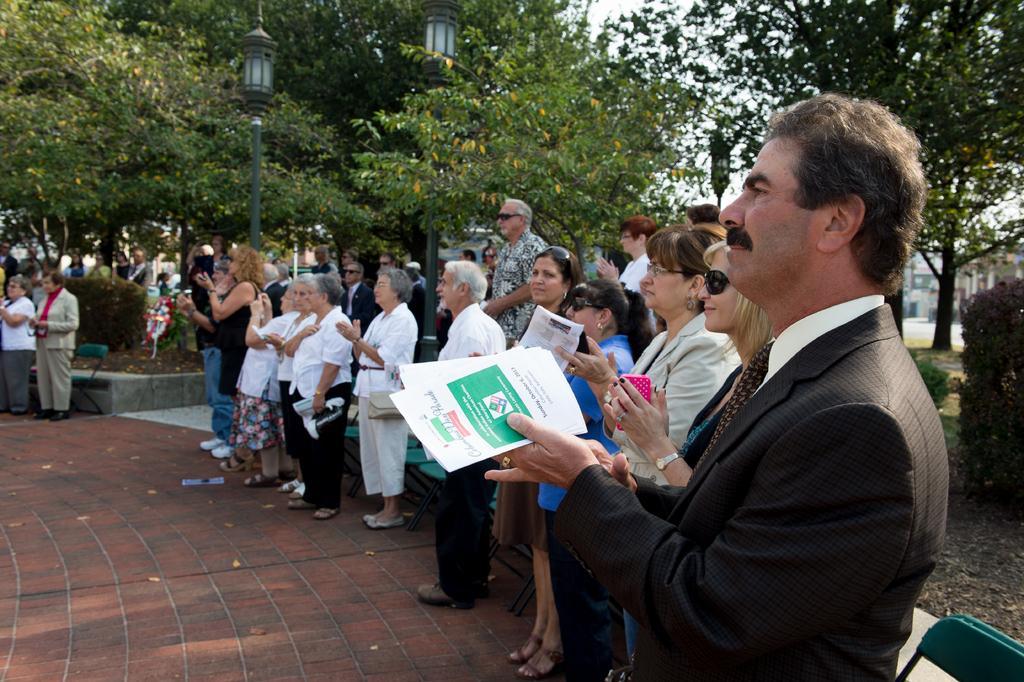Describe this image in one or two sentences. In this picture we can see many people standing here and clapping. and we can see this person wearing a suit and holding some papers with his hand. And in the background we can observe many trees and these are the plants. This is the pole with the lamp. Even we can observe the sky in the background. And this is the floor. 